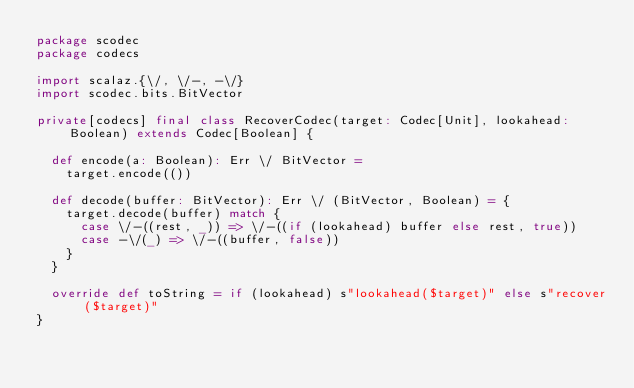Convert code to text. <code><loc_0><loc_0><loc_500><loc_500><_Scala_>package scodec
package codecs

import scalaz.{\/, \/-, -\/}
import scodec.bits.BitVector

private[codecs] final class RecoverCodec(target: Codec[Unit], lookahead: Boolean) extends Codec[Boolean] {

  def encode(a: Boolean): Err \/ BitVector =
    target.encode(())

  def decode(buffer: BitVector): Err \/ (BitVector, Boolean) = {
    target.decode(buffer) match {
      case \/-((rest, _)) => \/-((if (lookahead) buffer else rest, true))
      case -\/(_) => \/-((buffer, false))
    }
  }

  override def toString = if (lookahead) s"lookahead($target)" else s"recover($target)"
}
</code> 